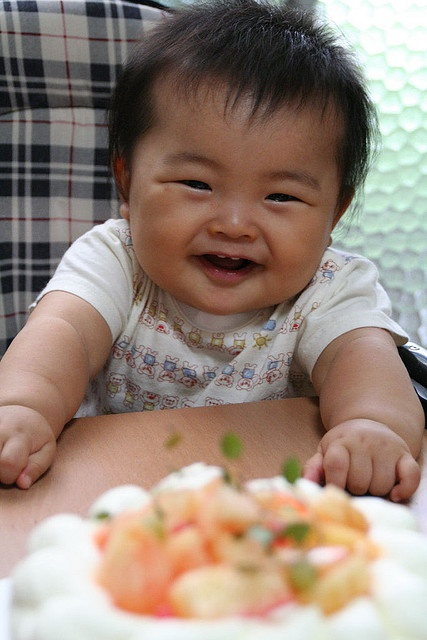Describe the objects in this image and their specific colors. I can see people in lavender, gray, black, and darkgray tones, cake in lavender, white, and tan tones, and dining table in lavender, gray, tan, and olive tones in this image. 